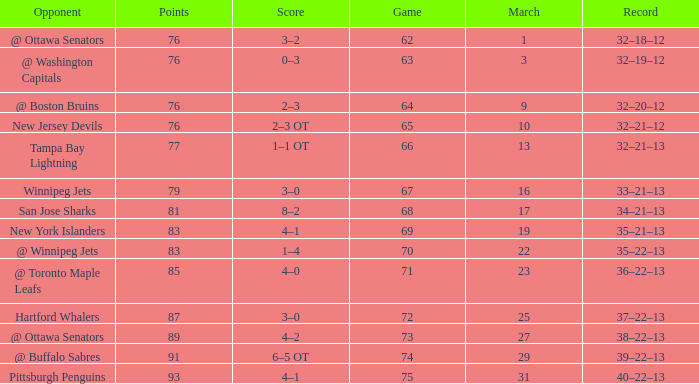How many games have a March of 19, and Points smaller than 83? 0.0. 